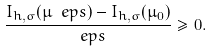Convert formula to latex. <formula><loc_0><loc_0><loc_500><loc_500>\frac { I _ { h , \sigma } ( \mu _ { \ } e p s ) - I _ { h , \sigma } ( \mu _ { 0 } ) } { \ e p s } \geq 0 .</formula> 